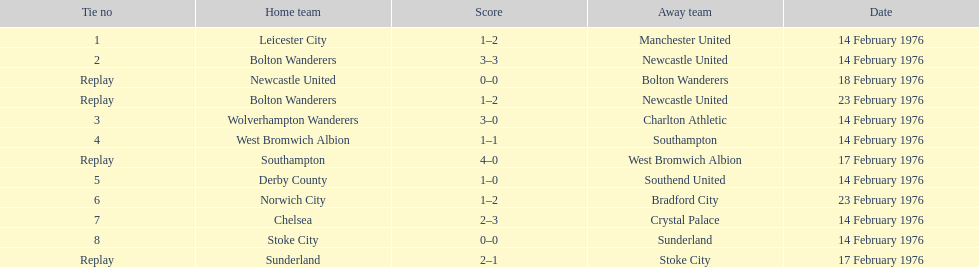On february 14th, 1976, what was the total number of teams that participated? 7. 